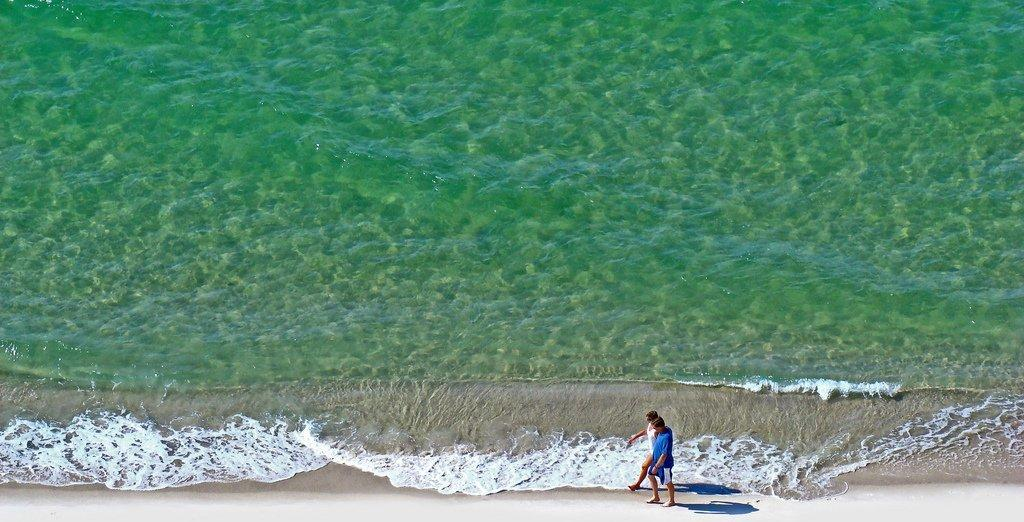What are the two people in the image doing? The two people in the image are walking. What natural feature is visible in the background of the image? There is a sea in the image. What type of terrain is at the bottom of the image? There is a seashore at the bottom of the image. How many children are playing on the range in the image? There are no children or range present in the image; it features two people walking near a sea and seashore. 